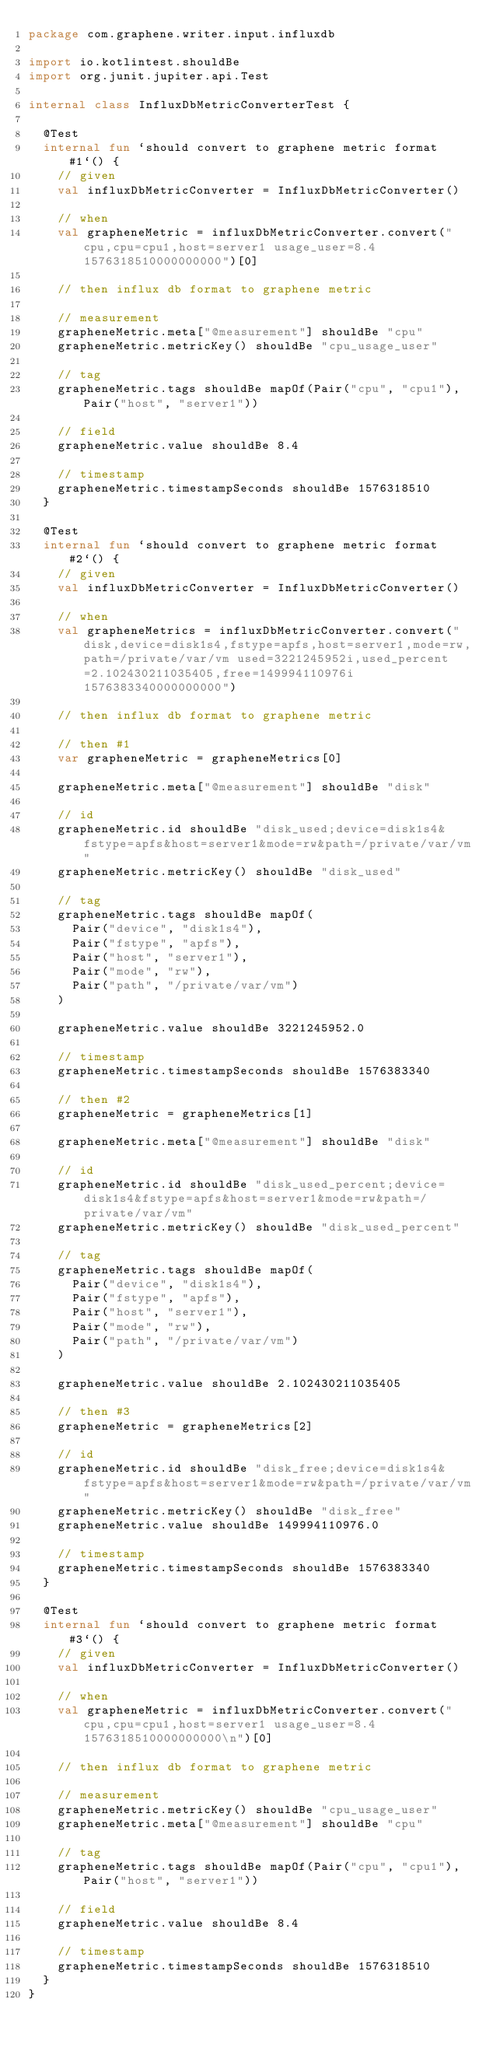Convert code to text. <code><loc_0><loc_0><loc_500><loc_500><_Kotlin_>package com.graphene.writer.input.influxdb

import io.kotlintest.shouldBe
import org.junit.jupiter.api.Test

internal class InfluxDbMetricConverterTest {

  @Test
  internal fun `should convert to graphene metric format#1`() {
    // given
    val influxDbMetricConverter = InfluxDbMetricConverter()

    // when
    val grapheneMetric = influxDbMetricConverter.convert("cpu,cpu=cpu1,host=server1 usage_user=8.4 1576318510000000000")[0]

    // then influx db format to graphene metric

    // measurement
    grapheneMetric.meta["@measurement"] shouldBe "cpu"
    grapheneMetric.metricKey() shouldBe "cpu_usage_user"

    // tag
    grapheneMetric.tags shouldBe mapOf(Pair("cpu", "cpu1"), Pair("host", "server1"))

    // field
    grapheneMetric.value shouldBe 8.4

    // timestamp
    grapheneMetric.timestampSeconds shouldBe 1576318510
  }

  @Test
  internal fun `should convert to graphene metric format#2`() {
    // given
    val influxDbMetricConverter = InfluxDbMetricConverter()

    // when
    val grapheneMetrics = influxDbMetricConverter.convert("disk,device=disk1s4,fstype=apfs,host=server1,mode=rw,path=/private/var/vm used=3221245952i,used_percent=2.102430211035405,free=149994110976i 1576383340000000000")

    // then influx db format to graphene metric

    // then #1
    var grapheneMetric = grapheneMetrics[0]

    grapheneMetric.meta["@measurement"] shouldBe "disk"

    // id
    grapheneMetric.id shouldBe "disk_used;device=disk1s4&fstype=apfs&host=server1&mode=rw&path=/private/var/vm"
    grapheneMetric.metricKey() shouldBe "disk_used"

    // tag
    grapheneMetric.tags shouldBe mapOf(
      Pair("device", "disk1s4"),
      Pair("fstype", "apfs"),
      Pair("host", "server1"),
      Pair("mode", "rw"),
      Pair("path", "/private/var/vm")
    )

    grapheneMetric.value shouldBe 3221245952.0

    // timestamp
    grapheneMetric.timestampSeconds shouldBe 1576383340

    // then #2
    grapheneMetric = grapheneMetrics[1]

    grapheneMetric.meta["@measurement"] shouldBe "disk"

    // id
    grapheneMetric.id shouldBe "disk_used_percent;device=disk1s4&fstype=apfs&host=server1&mode=rw&path=/private/var/vm"
    grapheneMetric.metricKey() shouldBe "disk_used_percent"

    // tag
    grapheneMetric.tags shouldBe mapOf(
      Pair("device", "disk1s4"),
      Pair("fstype", "apfs"),
      Pair("host", "server1"),
      Pair("mode", "rw"),
      Pair("path", "/private/var/vm")
    )

    grapheneMetric.value shouldBe 2.102430211035405

    // then #3
    grapheneMetric = grapheneMetrics[2]

    // id
    grapheneMetric.id shouldBe "disk_free;device=disk1s4&fstype=apfs&host=server1&mode=rw&path=/private/var/vm"
    grapheneMetric.metricKey() shouldBe "disk_free"
    grapheneMetric.value shouldBe 149994110976.0

    // timestamp
    grapheneMetric.timestampSeconds shouldBe 1576383340
  }

  @Test
  internal fun `should convert to graphene metric format#3`() {
    // given
    val influxDbMetricConverter = InfluxDbMetricConverter()

    // when
    val grapheneMetric = influxDbMetricConverter.convert("cpu,cpu=cpu1,host=server1 usage_user=8.4 1576318510000000000\n")[0]

    // then influx db format to graphene metric

    // measurement
    grapheneMetric.metricKey() shouldBe "cpu_usage_user"
    grapheneMetric.meta["@measurement"] shouldBe "cpu"

    // tag
    grapheneMetric.tags shouldBe mapOf(Pair("cpu", "cpu1"), Pair("host", "server1"))

    // field
    grapheneMetric.value shouldBe 8.4

    // timestamp
    grapheneMetric.timestampSeconds shouldBe 1576318510
  }
}
</code> 